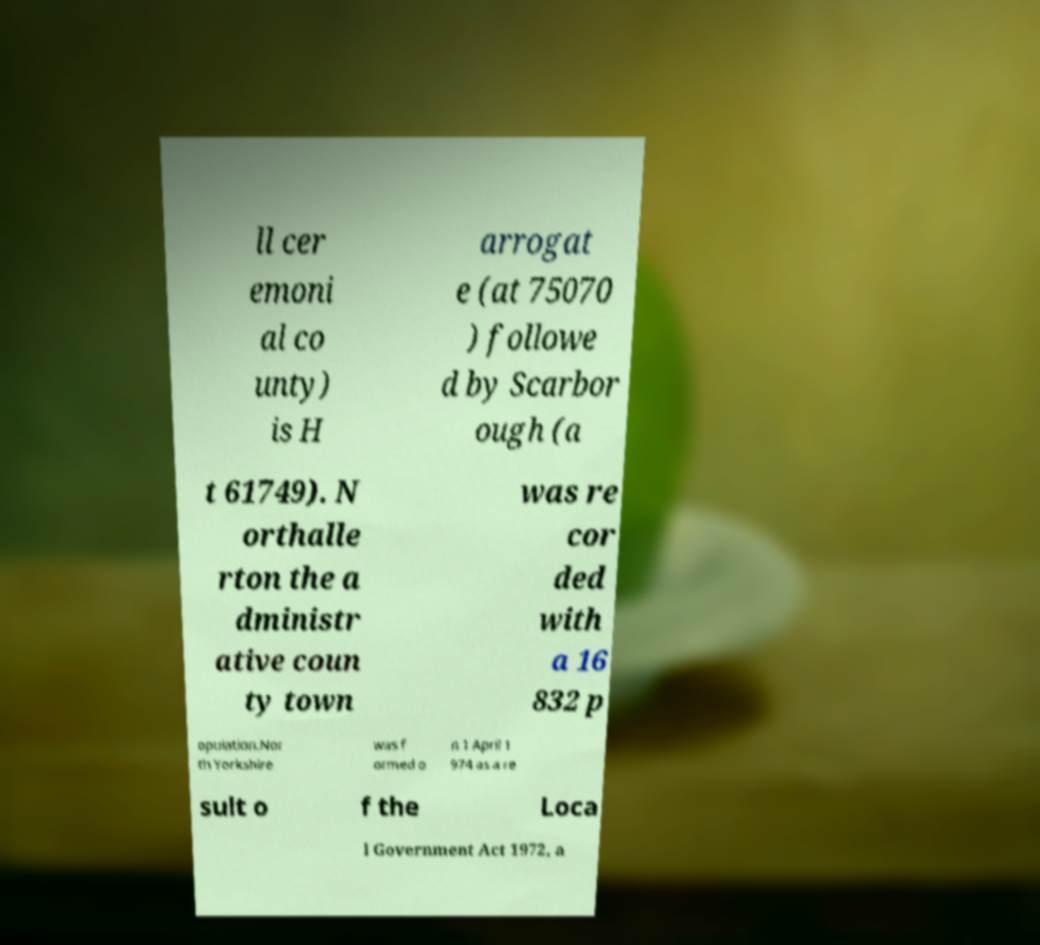Can you read and provide the text displayed in the image?This photo seems to have some interesting text. Can you extract and type it out for me? ll cer emoni al co unty) is H arrogat e (at 75070 ) followe d by Scarbor ough (a t 61749). N orthalle rton the a dministr ative coun ty town was re cor ded with a 16 832 p opulation.Nor th Yorkshire was f ormed o n 1 April 1 974 as a re sult o f the Loca l Government Act 1972, a 